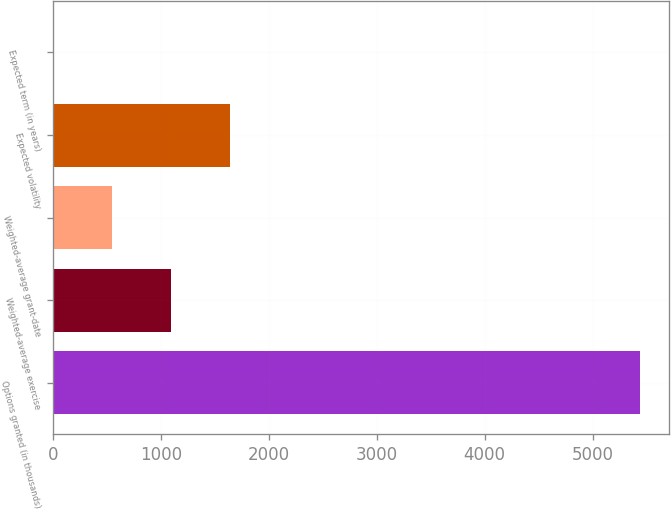Convert chart. <chart><loc_0><loc_0><loc_500><loc_500><bar_chart><fcel>Options granted (in thousands)<fcel>Weighted-average exercise<fcel>Weighted-average grant-date<fcel>Expected volatility<fcel>Expected term (in years)<nl><fcel>5438<fcel>1091.6<fcel>548.3<fcel>1634.9<fcel>5<nl></chart> 